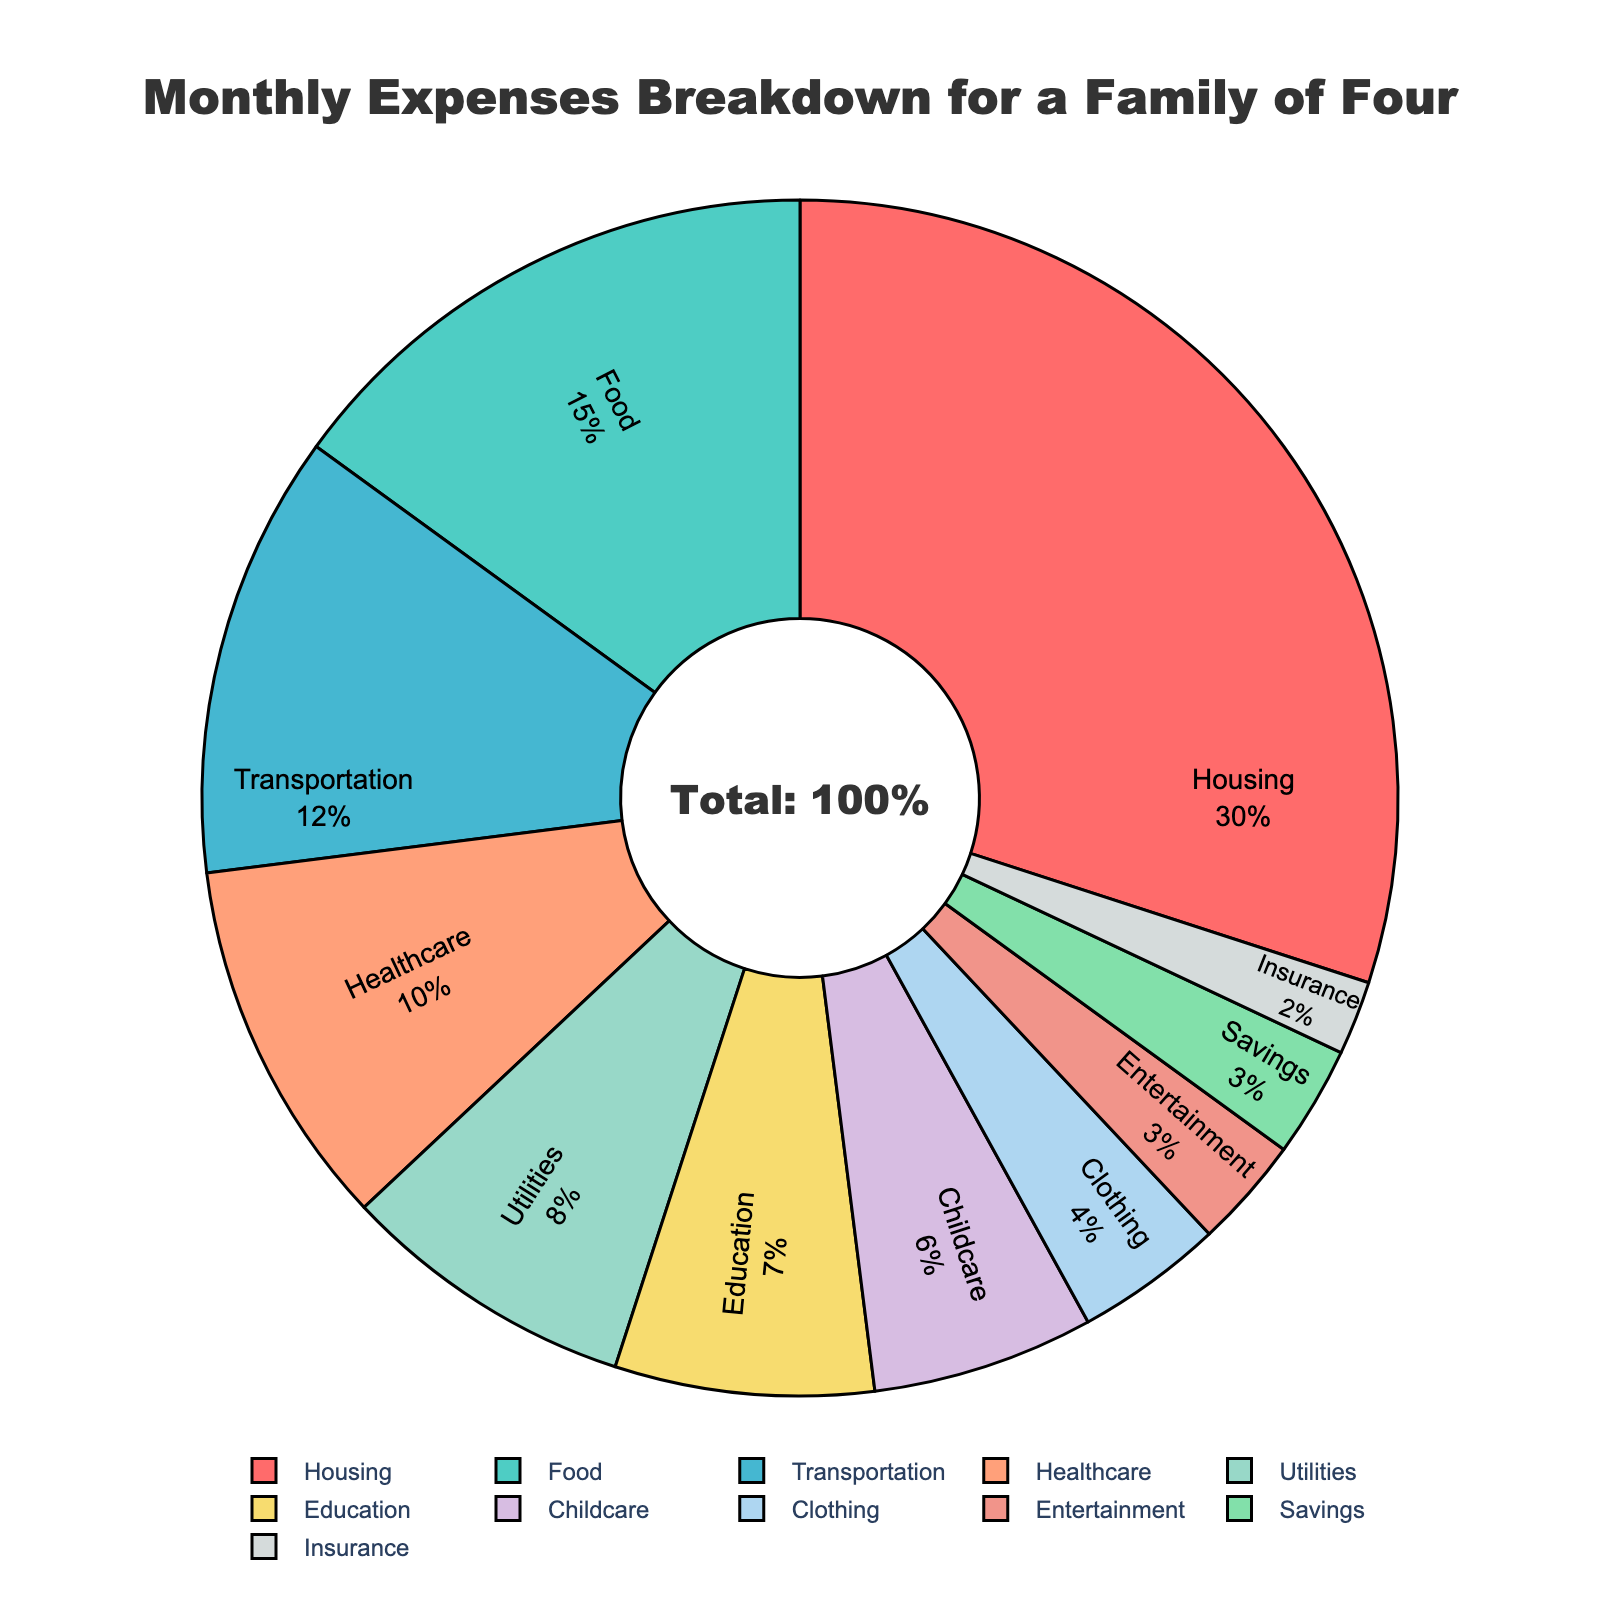What category takes up the largest percentage of monthly expenses? The largest segment of the pie chart in size represents the category with the highest percentage. In this case, Housing is the largest segment.
Answer: Housing Which category has a smaller percentage: Education or Childcare? We compare the percentages for Education and Childcare. Education has 7% whereas Childcare has 6%. Therefore, Childcare has a smaller percentage than Education.
Answer: Childcare What's the combined percentage of Food, Healthcare, and Utilities expenses? Adding the percentages of Food (15%), Healthcare (10%), and Utilities (8%) gives the combined percentage: 15% + 10% + 8% = 33%.
Answer: 33% Is the percentage of Transportation expenses greater than that of Food expenses? Transportation has a percentage of 12% and Food has a percentage of 15%. Comparing the two, Transportation is not greater than Food.
Answer: No What is the difference in percentage between Clothing and Entertainment? The percentage for Clothing is 4% and for Entertainment is 3%. The difference is calculated as: 4% - 3% = 1%.
Answer: 1% Which category has a lower percentage, Savings or Insurance? Comparing Savings at 3% and Insurance at 2%, it is clear that Insurance has the lower percentage.
Answer: Insurance What is the average percentage of Housing, Food, and Transportation expenses? The sum of Housing, Food, and Transportation percentages is 30% + 15% + 12% = 57%. The average is found by dividing this sum by 3: 57% / 3 = 19%.
Answer: 19% Which two categories each take up more than 10% of the monthly expenses? According to the pie chart, Housing (30%) and Food (15%) are the only categories that are each more than 10%.
Answer: Housing and Food What are the top three categories making the highest percentage in descending order? The top three categories with the highest percentages are Housing (30%), Food (15%), and Transportation (12%). So, in descending order, they are Housing, Food, and Transportation.
Answer: Housing, Food, Transportation 